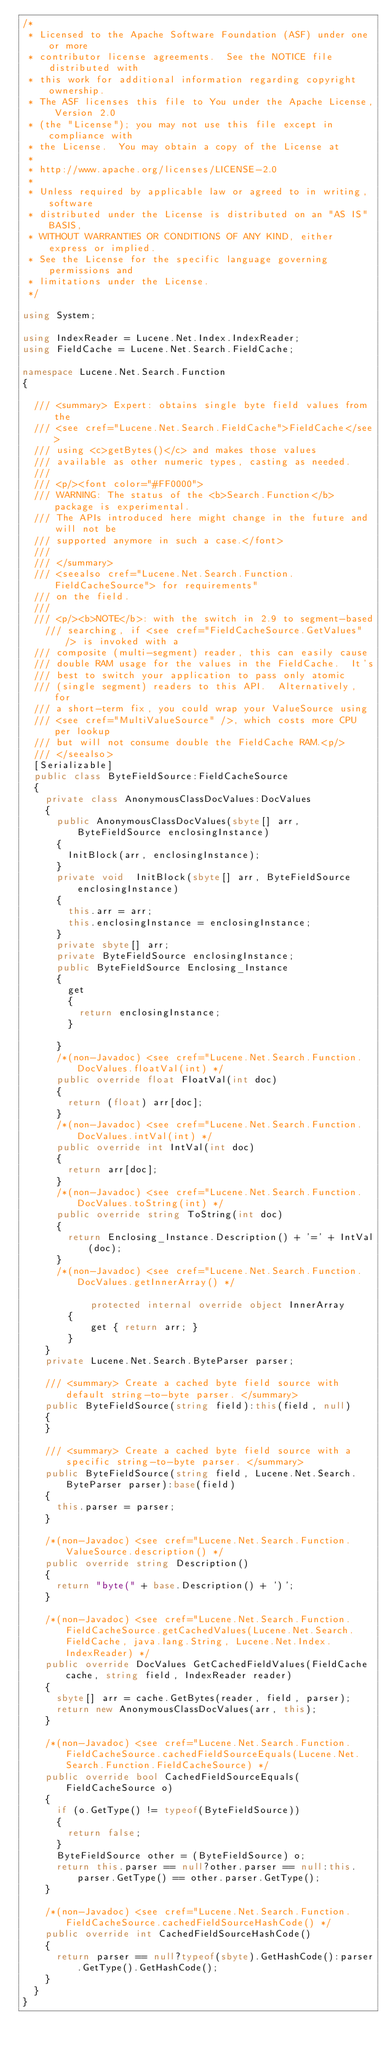<code> <loc_0><loc_0><loc_500><loc_500><_C#_>/* 
 * Licensed to the Apache Software Foundation (ASF) under one or more
 * contributor license agreements.  See the NOTICE file distributed with
 * this work for additional information regarding copyright ownership.
 * The ASF licenses this file to You under the Apache License, Version 2.0
 * (the "License"); you may not use this file except in compliance with
 * the License.  You may obtain a copy of the License at
 * 
 * http://www.apache.org/licenses/LICENSE-2.0
 * 
 * Unless required by applicable law or agreed to in writing, software
 * distributed under the License is distributed on an "AS IS" BASIS,
 * WITHOUT WARRANTIES OR CONDITIONS OF ANY KIND, either express or implied.
 * See the License for the specific language governing permissions and
 * limitations under the License.
 */

using System;

using IndexReader = Lucene.Net.Index.IndexReader;
using FieldCache = Lucene.Net.Search.FieldCache;

namespace Lucene.Net.Search.Function
{
	
	/// <summary> Expert: obtains single byte field values from the 
	/// <see cref="Lucene.Net.Search.FieldCache">FieldCache</see>
	/// using <c>getBytes()</c> and makes those values 
	/// available as other numeric types, casting as needed.
	/// 
	/// <p/><font color="#FF0000">
	/// WARNING: The status of the <b>Search.Function</b> package is experimental. 
	/// The APIs introduced here might change in the future and will not be 
	/// supported anymore in such a case.</font>
	/// 
	/// </summary>
	/// <seealso cref="Lucene.Net.Search.Function.FieldCacheSource"> for requirements"
	/// on the field. 
	/// 
	/// <p/><b>NOTE</b>: with the switch in 2.9 to segment-based
    /// searching, if <see cref="FieldCacheSource.GetValues" /> is invoked with a
	/// composite (multi-segment) reader, this can easily cause
	/// double RAM usage for the values in the FieldCache.  It's
	/// best to switch your application to pass only atomic
	/// (single segment) readers to this API.  Alternatively, for
	/// a short-term fix, you could wrap your ValueSource using
	/// <see cref="MultiValueSource" />, which costs more CPU per lookup
	/// but will not consume double the FieldCache RAM.<p/>
	/// </seealso>
	[Serializable]
	public class ByteFieldSource:FieldCacheSource
	{
		private class AnonymousClassDocValues:DocValues
		{
			public AnonymousClassDocValues(sbyte[] arr, ByteFieldSource enclosingInstance)
			{
				InitBlock(arr, enclosingInstance);
			}
			private void  InitBlock(sbyte[] arr, ByteFieldSource enclosingInstance)
			{
				this.arr = arr;
				this.enclosingInstance = enclosingInstance;
			}
			private sbyte[] arr;
			private ByteFieldSource enclosingInstance;
			public ByteFieldSource Enclosing_Instance
			{
				get
				{
					return enclosingInstance;
				}
				
			}
			/*(non-Javadoc) <see cref="Lucene.Net.Search.Function.DocValues.floatVal(int) */
			public override float FloatVal(int doc)
			{
				return (float) arr[doc];
			}
			/*(non-Javadoc) <see cref="Lucene.Net.Search.Function.DocValues.intVal(int) */
			public override int IntVal(int doc)
			{
				return arr[doc];
			}
			/*(non-Javadoc) <see cref="Lucene.Net.Search.Function.DocValues.toString(int) */
			public override string ToString(int doc)
			{
				return Enclosing_Instance.Description() + '=' + IntVal(doc);
			}
			/*(non-Javadoc) <see cref="Lucene.Net.Search.Function.DocValues.getInnerArray() */

            protected internal override object InnerArray
		    {
		        get { return arr; }
		    }
		}
		private Lucene.Net.Search.ByteParser parser;
		
		/// <summary> Create a cached byte field source with default string-to-byte parser. </summary>
		public ByteFieldSource(string field):this(field, null)
		{
		}
		
		/// <summary> Create a cached byte field source with a specific string-to-byte parser. </summary>
		public ByteFieldSource(string field, Lucene.Net.Search.ByteParser parser):base(field)
		{
			this.parser = parser;
		}
		
		/*(non-Javadoc) <see cref="Lucene.Net.Search.Function.ValueSource.description() */
		public override string Description()
		{
			return "byte(" + base.Description() + ')';
		}
		
		/*(non-Javadoc) <see cref="Lucene.Net.Search.Function.FieldCacheSource.getCachedValues(Lucene.Net.Search.FieldCache, java.lang.String, Lucene.Net.Index.IndexReader) */
		public override DocValues GetCachedFieldValues(FieldCache cache, string field, IndexReader reader)
		{
			sbyte[] arr = cache.GetBytes(reader, field, parser);
			return new AnonymousClassDocValues(arr, this);
		}
		
		/*(non-Javadoc) <see cref="Lucene.Net.Search.Function.FieldCacheSource.cachedFieldSourceEquals(Lucene.Net.Search.Function.FieldCacheSource) */
		public override bool CachedFieldSourceEquals(FieldCacheSource o)
		{
			if (o.GetType() != typeof(ByteFieldSource))
			{
				return false;
			}
			ByteFieldSource other = (ByteFieldSource) o;
			return this.parser == null?other.parser == null:this.parser.GetType() == other.parser.GetType();
		}
		
		/*(non-Javadoc) <see cref="Lucene.Net.Search.Function.FieldCacheSource.cachedFieldSourceHashCode() */
		public override int CachedFieldSourceHashCode()
		{
			return parser == null?typeof(sbyte).GetHashCode():parser.GetType().GetHashCode();
		}
	}
}</code> 